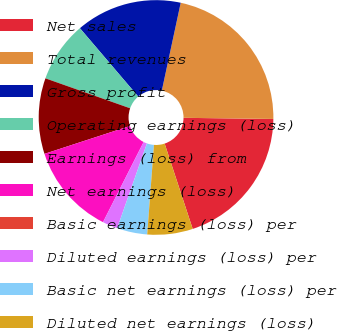Convert chart. <chart><loc_0><loc_0><loc_500><loc_500><pie_chart><fcel>Net sales<fcel>Total revenues<fcel>Gross profit<fcel>Operating earnings (loss)<fcel>Earnings (loss) from<fcel>Net earnings (loss)<fcel>Basic earnings (loss) per<fcel>Diluted earnings (loss) per<fcel>Basic net earnings (loss) per<fcel>Diluted net earnings (loss)<nl><fcel>19.74%<fcel>21.83%<fcel>14.61%<fcel>8.35%<fcel>10.43%<fcel>12.52%<fcel>0.0%<fcel>2.09%<fcel>4.17%<fcel>6.26%<nl></chart> 